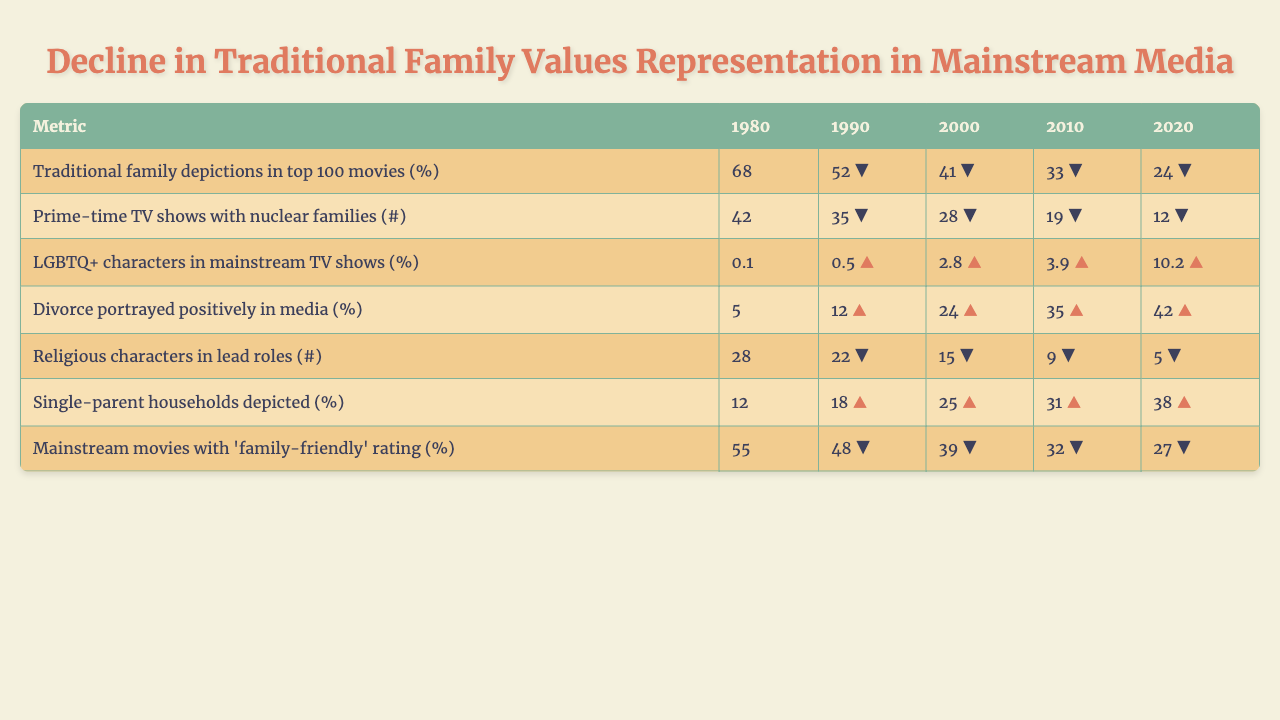What percentage of traditional family depictions were in the top 100 movies in 1980? In the table, under the metric "Traditional family depictions in top 100 movies (%)" for the year 1980, the value is 68%.
Answer: 68% How many prime-time TV shows featured nuclear families in 2010? The table shows the number of prime-time TV shows with nuclear families for the year 2010 is 19.
Answer: 19 What was the percentage increase of LGBTQ+ characters in mainstream TV shows from 2000 to 2020? From 2000, the percentage of LGBTQ+ characters was 2.8%, and in 2020, it was 10.2%. The increase is calculated as 10.2% - 2.8% = 7.4%.
Answer: 7.4% Was there a positive portrayal of divorce in media in 1980? According to the table, 5% of divorce was portrayed positively in media in 1980, which is not positively significant.
Answer: No What is the percentage of single-parent households depicted in 2000 compared to 1980? The value for single-parent households depicted in 2000 is 25% and for 1980 is 12%. The difference is 25% - 12% = 13%.
Answer: 13% How did the number of religious characters in lead roles change from 1980 to 2020? In 1980, there were 28 religious characters, and by 2020, this number dropped to 5. The change is 28 - 5 = 23 fewer characters.
Answer: 23 What is the trend for traditional family depictions in top 100 movies from 1980 to 2020? The values for traditional family depictions are 68% in 1980, decreasing to 24% in 2020. The numbers are consistently decreasing over the decades indicating a decline in this representation.
Answer: Decline What was the average percentage of mainstream movies with 'family-friendly' ratings from 1980 to 2020? The values are 55%, 48%, 39%, 32%, and 27%. To find the average, sum these values: 55 + 48 + 39 + 32 + 27 = 201, then divide by 5, giving 201 / 5 = 40.2%.
Answer: 40.2% Which metric showed the largest percentage decrease from 1980 to 2020? The "Traditional family depictions in top 100 movies (%)" showed a decrease from 68% to 24%, which is a change of 44%. This is the largest decrease among the metrics in the table.
Answer: Traditional family depictions Did the percentage of nuclear families in prime-time TV shows increase or decrease from 1990 to 2010? In 1990, there were 35 shows, which decreased to 19 by 2010. This indicates a decrease in the number of prime-time TV shows featuring nuclear families during this period.
Answer: Decrease 